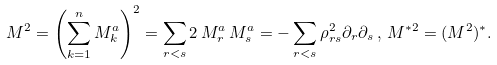Convert formula to latex. <formula><loc_0><loc_0><loc_500><loc_500>M ^ { 2 } = \left ( \sum _ { k = 1 } ^ { n } M _ { k } ^ { a } \right ) ^ { 2 } = \sum _ { r < s } 2 \, M _ { r } ^ { a } \, M _ { s } ^ { a } = - \sum _ { r < s } \rho _ { r s } ^ { 2 } \partial _ { r } \partial _ { s } \, , \, M ^ { * 2 } = ( M ^ { 2 } ) ^ { * } .</formula> 